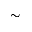Convert formula to latex. <formula><loc_0><loc_0><loc_500><loc_500>\sim</formula> 